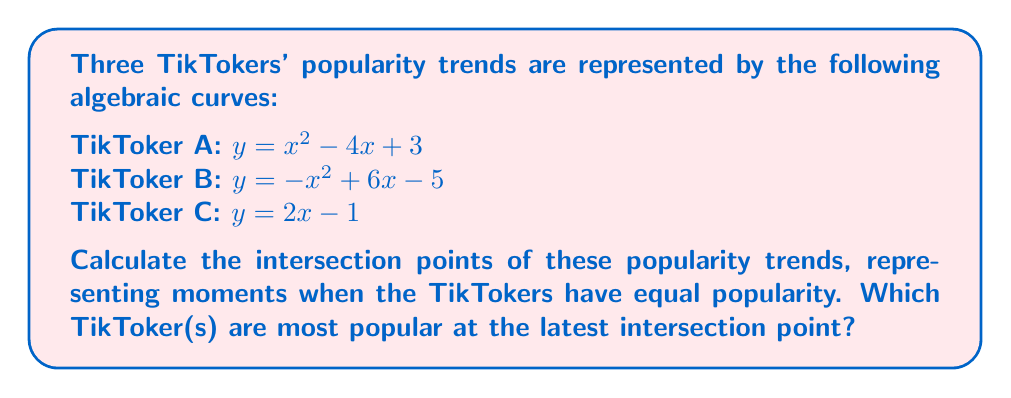What is the answer to this math problem? 1) First, we need to find the intersection points of these curves. We'll do this by solving the equations in pairs:

   A and B: $x^2 - 4x + 3 = -x^2 + 6x - 5$
   A and C: $x^2 - 4x + 3 = 2x - 1$
   B and C: $-x^2 + 6x - 5 = 2x - 1$

2) For A and B:
   $x^2 - 4x + 3 = -x^2 + 6x - 5$
   $2x^2 - 10x + 8 = 0$
   $2(x^2 - 5x + 4) = 0$
   $2(x - 1)(x - 4) = 0$
   $x = 1$ or $x = 4$

3) For A and C:
   $x^2 - 4x + 3 = 2x - 1$
   $x^2 - 6x + 4 = 0$
   $(x - 2)(x - 4) = 0$
   $x = 2$ or $x = 4$

4) For B and C:
   $-x^2 + 6x - 5 = 2x - 1$
   $-x^2 + 4x - 4 = 0$
   $-(x^2 - 4x + 4) = 0$
   $-(x - 2)^2 = 0$
   $x = 2$

5) Combining these results, we have intersection points at $x = 1, 2,$ and $4$.

6) To find the y-coordinates, we can substitute these x-values into any of the equations:

   At $x = 1$: $y = 1^2 - 4(1) + 3 = 0$
   At $x = 2$: $y = 2^2 - 4(2) + 3 = 3$
   At $x = 4$: $y = 4^2 - 4(4) + 3 = 7$

7) Therefore, the intersection points are $(1, 0)$, $(2, 3)$, and $(4, 7)$.

8) The latest intersection point is at $x = 4$, where $y = 7$.

9) To determine which TikToker(s) are most popular at this point, we need to compare the y-values of their curves for $x > 4$:

   For $x > 4$:
   A: $y = x^2 - 4x + 3$ (quadratic, opens upward)
   B: $y = -x^2 + 6x - 5$ (quadratic, opens downward)
   C: $y = 2x - 1$ (linear, increasing)

   TikToker A's curve will have the highest y-value for $x > 4$.
Answer: Intersection points: $(1, 0)$, $(2, 3)$, $(4, 7)$. TikToker A is most popular after the latest intersection point. 